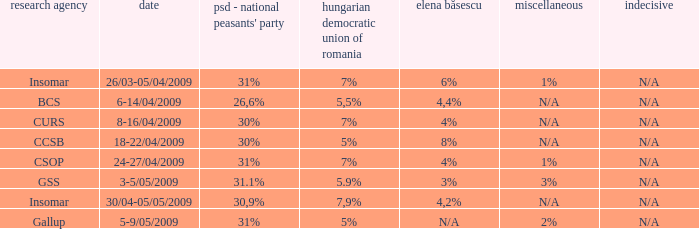When the other is n/a and the psc-pc is 30% what is the date? 8-16/04/2009, 18-22/04/2009. 